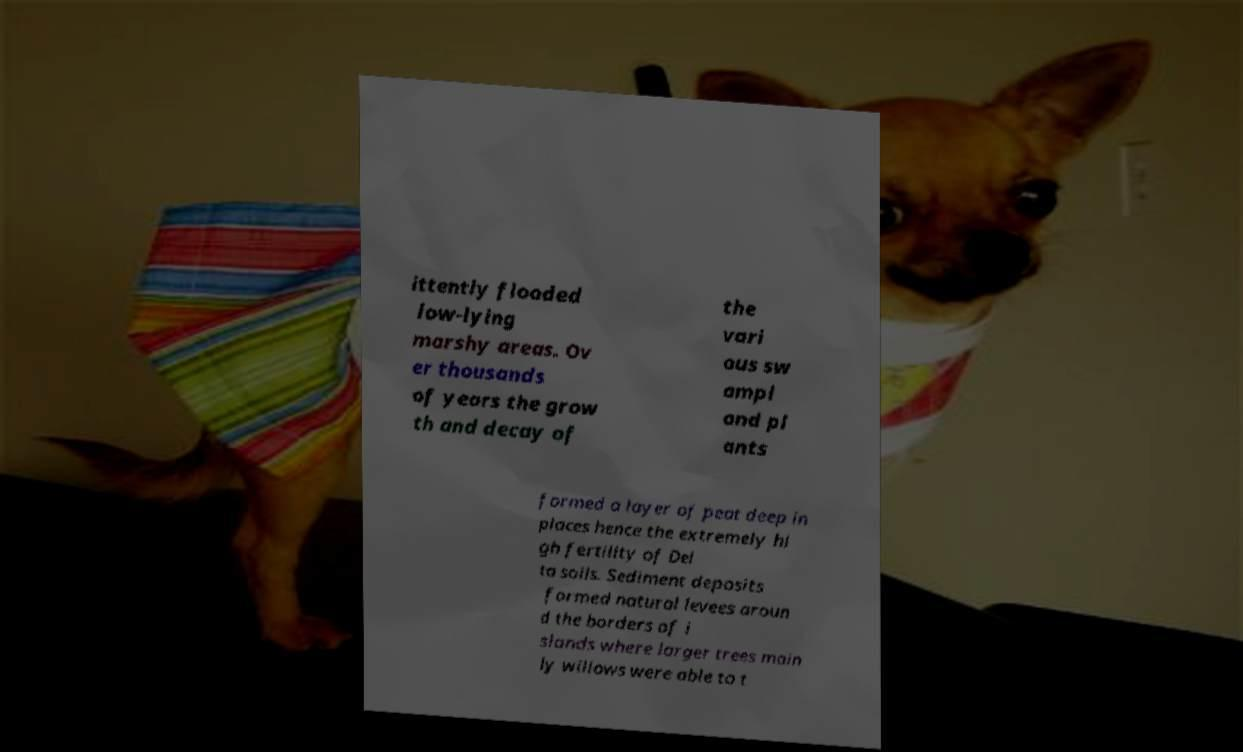Please read and relay the text visible in this image. What does it say? ittently flooded low-lying marshy areas. Ov er thousands of years the grow th and decay of the vari ous sw ampl and pl ants formed a layer of peat deep in places hence the extremely hi gh fertility of Del ta soils. Sediment deposits formed natural levees aroun d the borders of i slands where larger trees main ly willows were able to t 